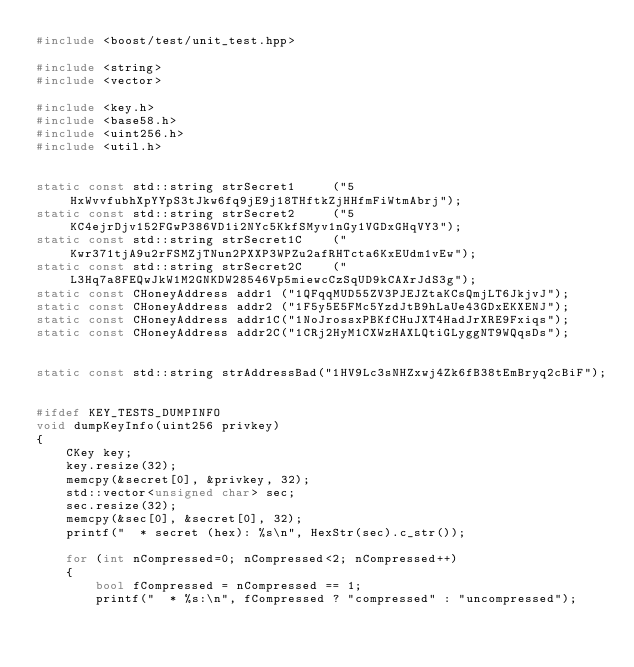Convert code to text. <code><loc_0><loc_0><loc_500><loc_500><_C++_>#include <boost/test/unit_test.hpp>

#include <string>
#include <vector>

#include <key.h>
#include <base58.h>
#include <uint256.h>
#include <util.h>


static const std::string strSecret1     ("5HxWvvfubhXpYYpS3tJkw6fq9jE9j18THftkZjHHfmFiWtmAbrj");
static const std::string strSecret2     ("5KC4ejrDjv152FGwP386VD1i2NYc5KkfSMyv1nGy1VGDxGHqVY3");
static const std::string strSecret1C    ("Kwr371tjA9u2rFSMZjTNun2PXXP3WPZu2afRHTcta6KxEUdm1vEw");
static const std::string strSecret2C    ("L3Hq7a8FEQwJkW1M2GNKDW28546Vp5miewcCzSqUD9kCAXrJdS3g");
static const CHoneyAddress addr1 ("1QFqqMUD55ZV3PJEJZtaKCsQmjLT6JkjvJ");
static const CHoneyAddress addr2 ("1F5y5E5FMc5YzdJtB9hLaUe43GDxEKXENJ");
static const CHoneyAddress addr1C("1NoJrossxPBKfCHuJXT4HadJrXRE9Fxiqs");
static const CHoneyAddress addr2C("1CRj2HyM1CXWzHAXLQtiGLyggNT9WQqsDs");


static const std::string strAddressBad("1HV9Lc3sNHZxwj4Zk6fB38tEmBryq2cBiF");


#ifdef KEY_TESTS_DUMPINFO
void dumpKeyInfo(uint256 privkey)
{
    CKey key;
    key.resize(32);
    memcpy(&secret[0], &privkey, 32);
    std::vector<unsigned char> sec;
    sec.resize(32);
    memcpy(&sec[0], &secret[0], 32);
    printf("  * secret (hex): %s\n", HexStr(sec).c_str());

    for (int nCompressed=0; nCompressed<2; nCompressed++)
    {
        bool fCompressed = nCompressed == 1;
        printf("  * %s:\n", fCompressed ? "compressed" : "uncompressed");</code> 